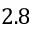<formula> <loc_0><loc_0><loc_500><loc_500>2 . 8</formula> 